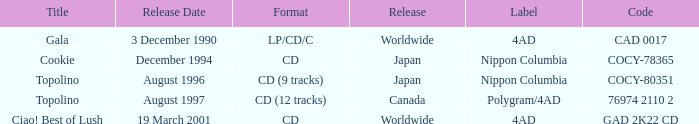What format was released in August 1996? CD (9 tracks). 